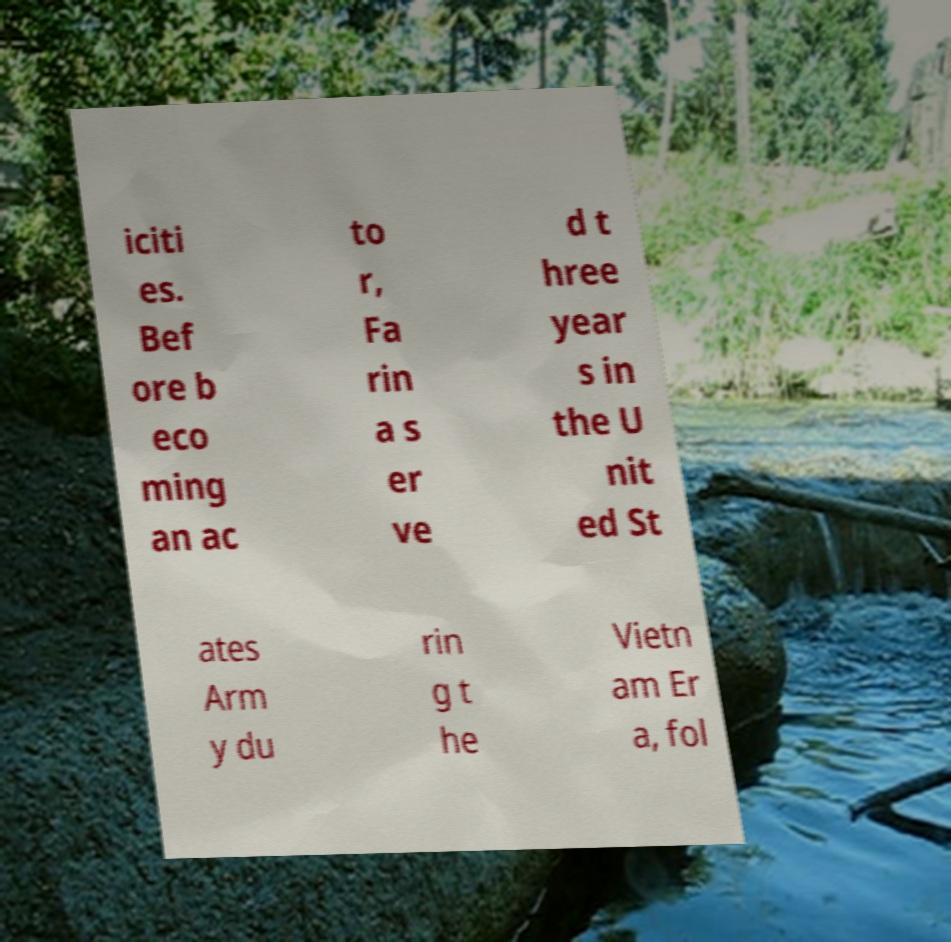Can you accurately transcribe the text from the provided image for me? iciti es. Bef ore b eco ming an ac to r, Fa rin a s er ve d t hree year s in the U nit ed St ates Arm y du rin g t he Vietn am Er a, fol 